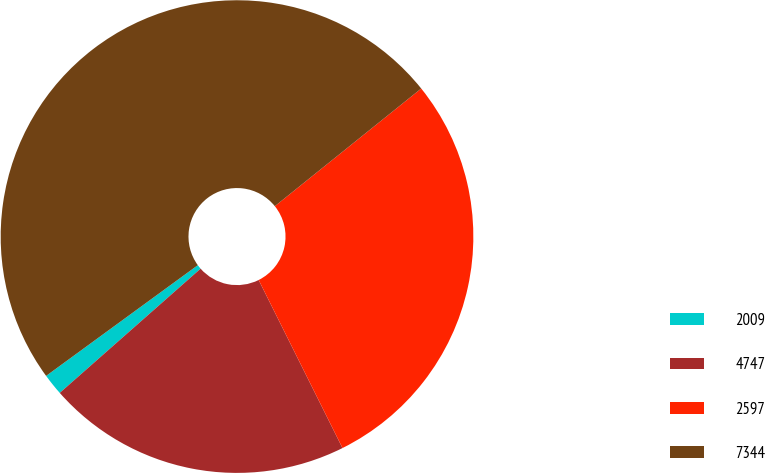Convert chart to OTSL. <chart><loc_0><loc_0><loc_500><loc_500><pie_chart><fcel>2009<fcel>4747<fcel>2597<fcel>7344<nl><fcel>1.47%<fcel>20.86%<fcel>28.41%<fcel>49.26%<nl></chart> 